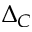<formula> <loc_0><loc_0><loc_500><loc_500>\Delta _ { C }</formula> 